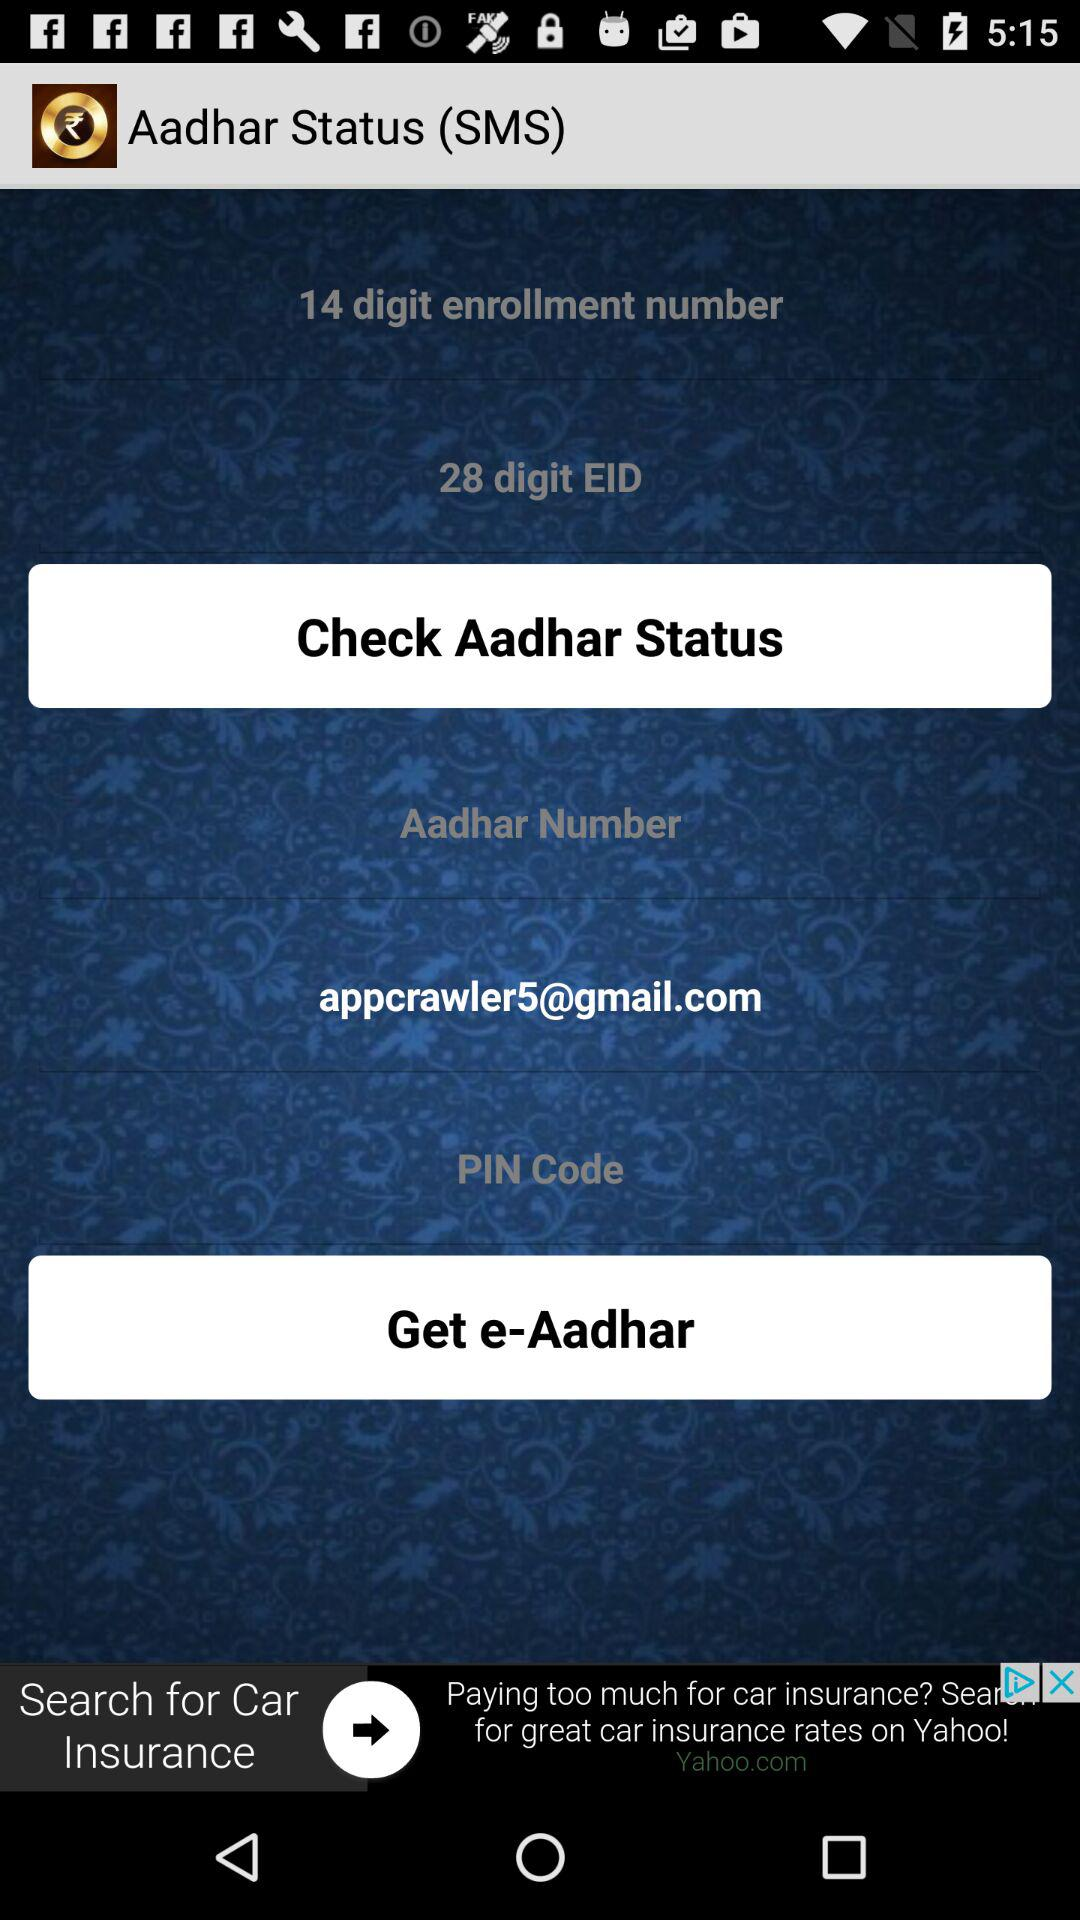What is the Gmail account? The Gmail account is appcrawler5@gmail.com. 